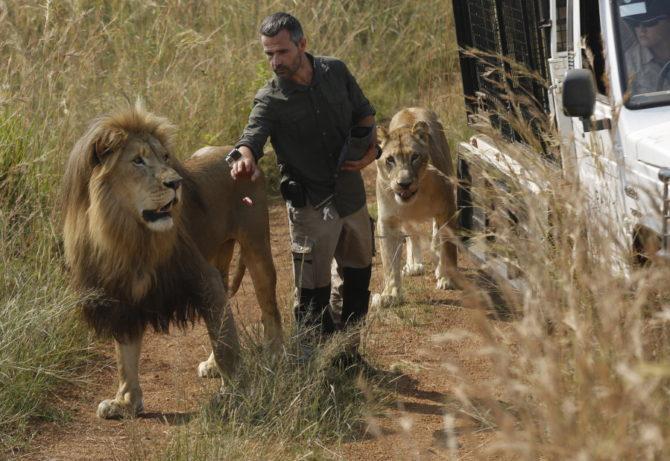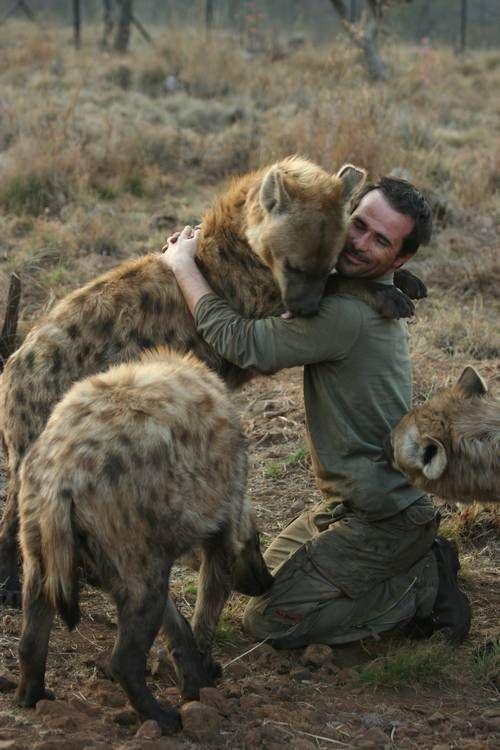The first image is the image on the left, the second image is the image on the right. For the images shown, is this caption "In at least one image, a man is hugging a hyena." true? Answer yes or no. Yes. The first image is the image on the left, the second image is the image on the right. Examine the images to the left and right. Is the description "There are two men interacting with one or more large cats." accurate? Answer yes or no. Yes. 